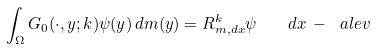Convert formula to latex. <formula><loc_0><loc_0><loc_500><loc_500>\int _ { \Omega } G _ { 0 } ( \cdot , y ; k ) \psi ( y ) \, d m ( y ) = R _ { m , d x } ^ { k } \psi \quad d x \, - \, \ a l e v</formula> 